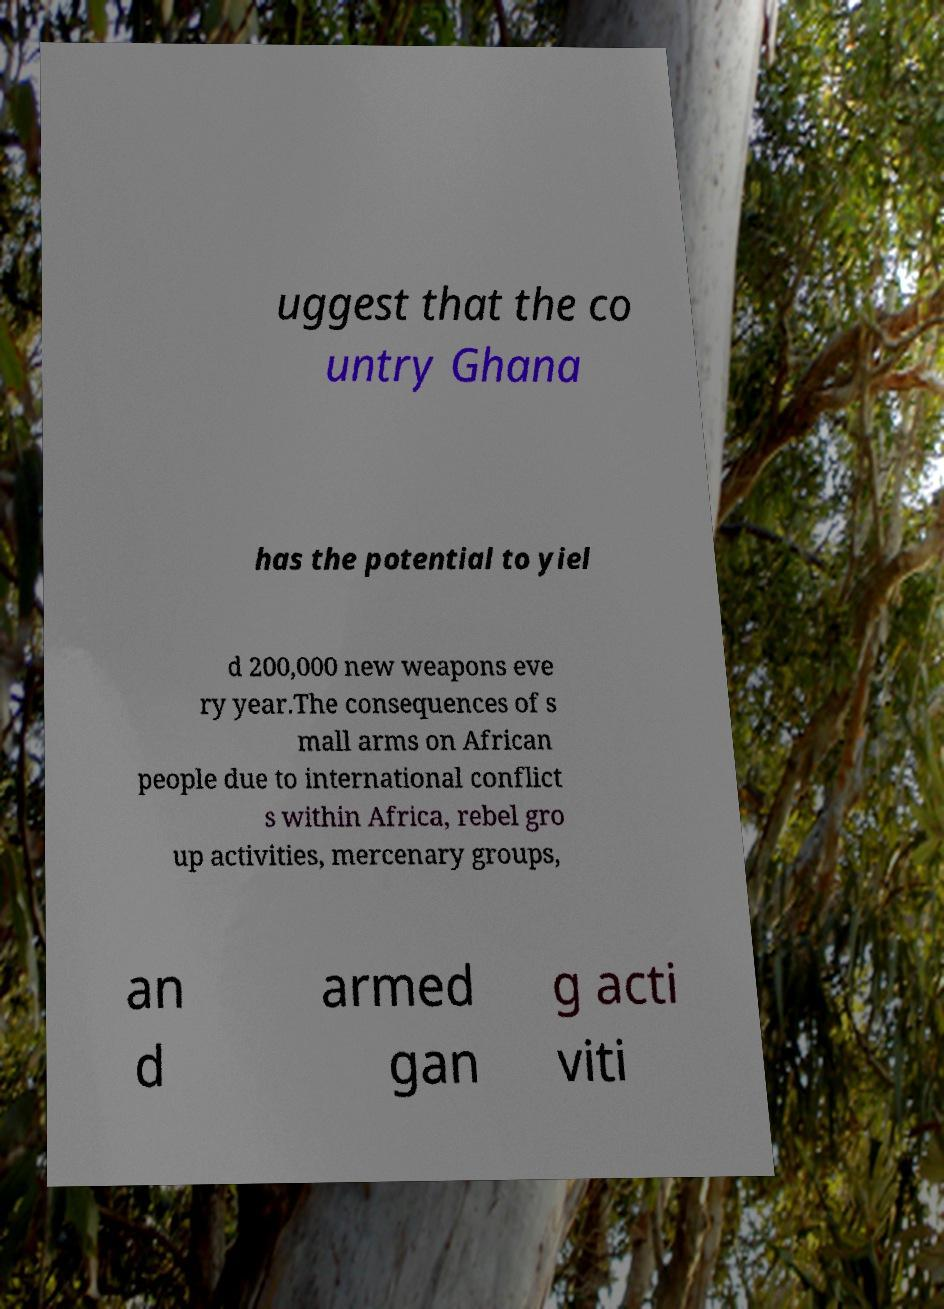Please read and relay the text visible in this image. What does it say? uggest that the co untry Ghana has the potential to yiel d 200,000 new weapons eve ry year.The consequences of s mall arms on African people due to international conflict s within Africa, rebel gro up activities, mercenary groups, an d armed gan g acti viti 